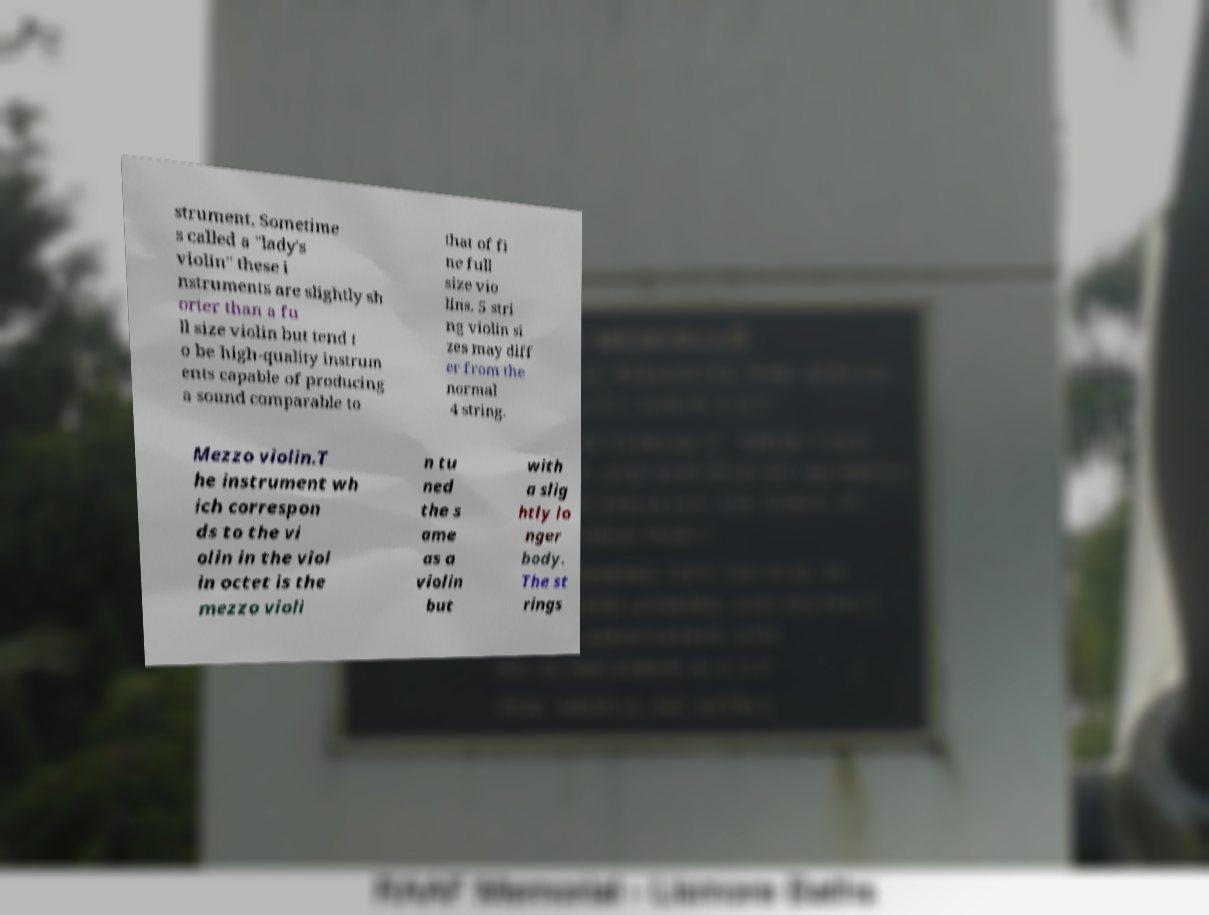Please identify and transcribe the text found in this image. strument. Sometime s called a "lady's violin" these i nstruments are slightly sh orter than a fu ll size violin but tend t o be high-quality instrum ents capable of producing a sound comparable to that of fi ne full size vio lins. 5 stri ng violin si zes may diff er from the normal 4 string. Mezzo violin.T he instrument wh ich correspon ds to the vi olin in the viol in octet is the mezzo violi n tu ned the s ame as a violin but with a slig htly lo nger body. The st rings 